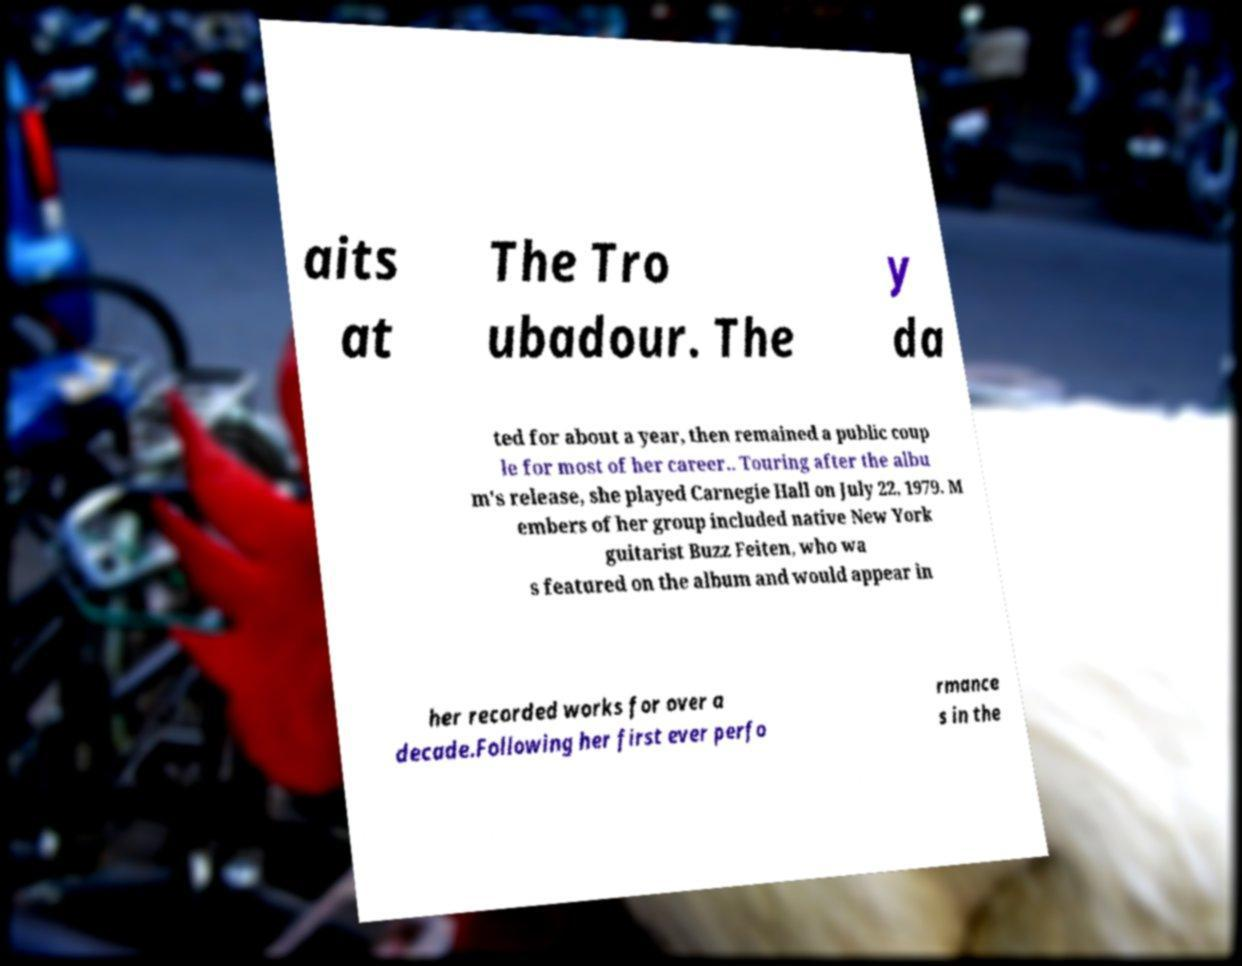For documentation purposes, I need the text within this image transcribed. Could you provide that? aits at The Tro ubadour. The y da ted for about a year, then remained a public coup le for most of her career.. Touring after the albu m's release, she played Carnegie Hall on July 22, 1979. M embers of her group included native New York guitarist Buzz Feiten, who wa s featured on the album and would appear in her recorded works for over a decade.Following her first ever perfo rmance s in the 